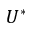<formula> <loc_0><loc_0><loc_500><loc_500>U ^ { * }</formula> 